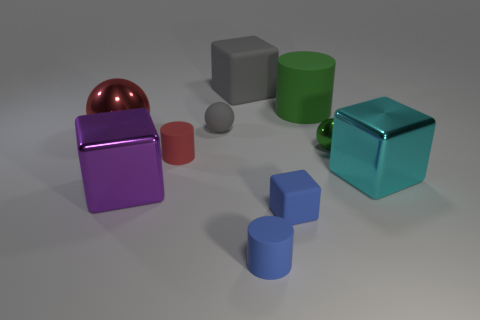Subtract all small green shiny balls. How many balls are left? 2 Subtract all green cylinders. How many cylinders are left? 2 Subtract all balls. How many objects are left? 7 Add 6 blue matte blocks. How many blue matte blocks exist? 7 Subtract 0 brown balls. How many objects are left? 10 Subtract 2 cylinders. How many cylinders are left? 1 Subtract all purple cylinders. Subtract all gray cubes. How many cylinders are left? 3 Subtract all green spheres. How many blue cylinders are left? 1 Subtract all large red matte blocks. Subtract all rubber spheres. How many objects are left? 9 Add 4 red matte things. How many red matte things are left? 5 